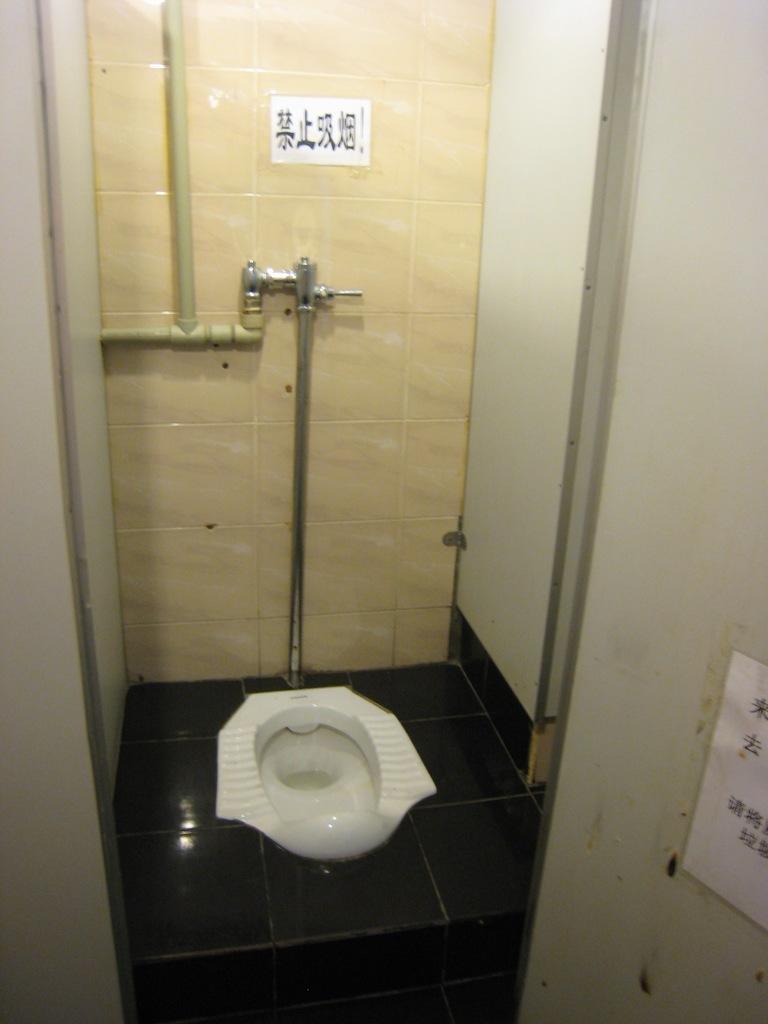Please provide a concise description of this image. In this picture we can see a commode in the middle, in the background there are some tiles and pipes, we can see a paper pasted at the right bottom. 